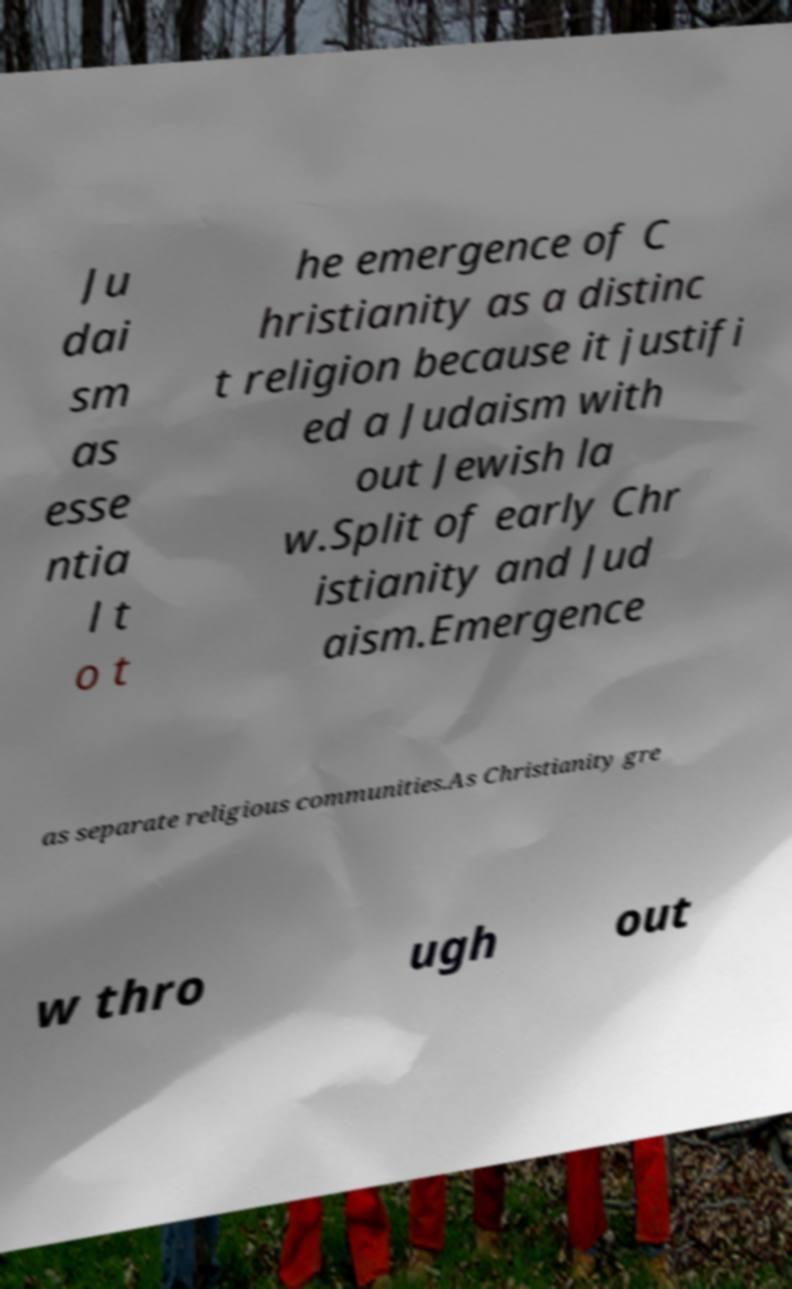Could you extract and type out the text from this image? Ju dai sm as esse ntia l t o t he emergence of C hristianity as a distinc t religion because it justifi ed a Judaism with out Jewish la w.Split of early Chr istianity and Jud aism.Emergence as separate religious communities.As Christianity gre w thro ugh out 